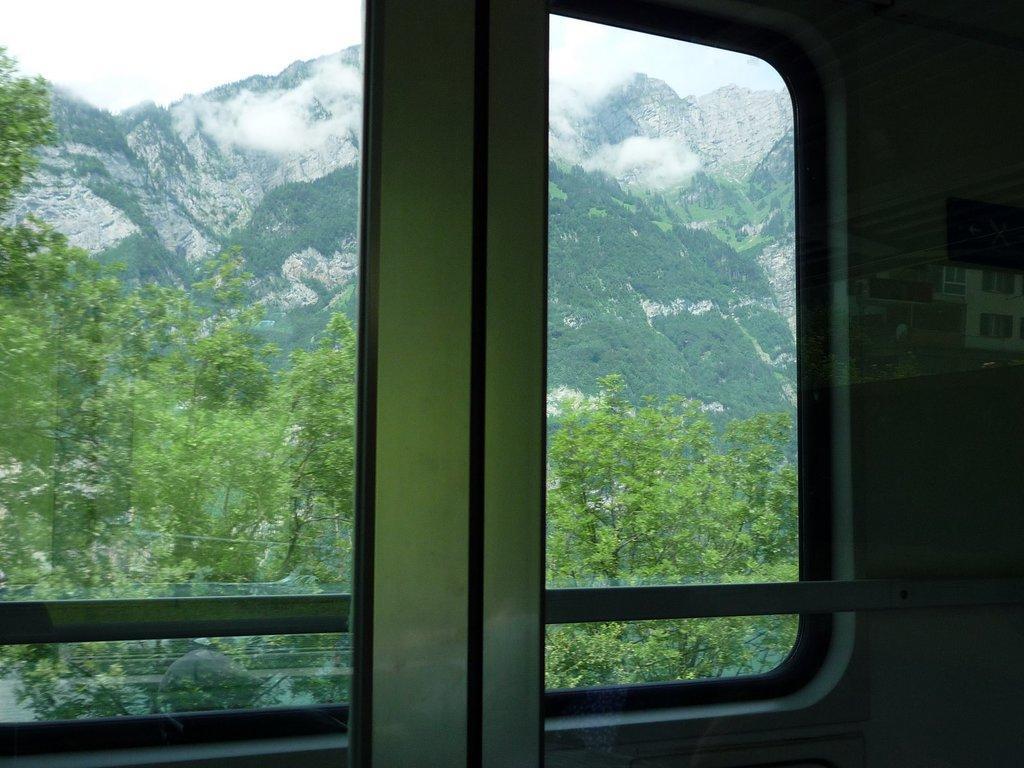Please provide a concise description of this image. In this image, we can see a view from the glass. We can see some trees, hills and the sky. 